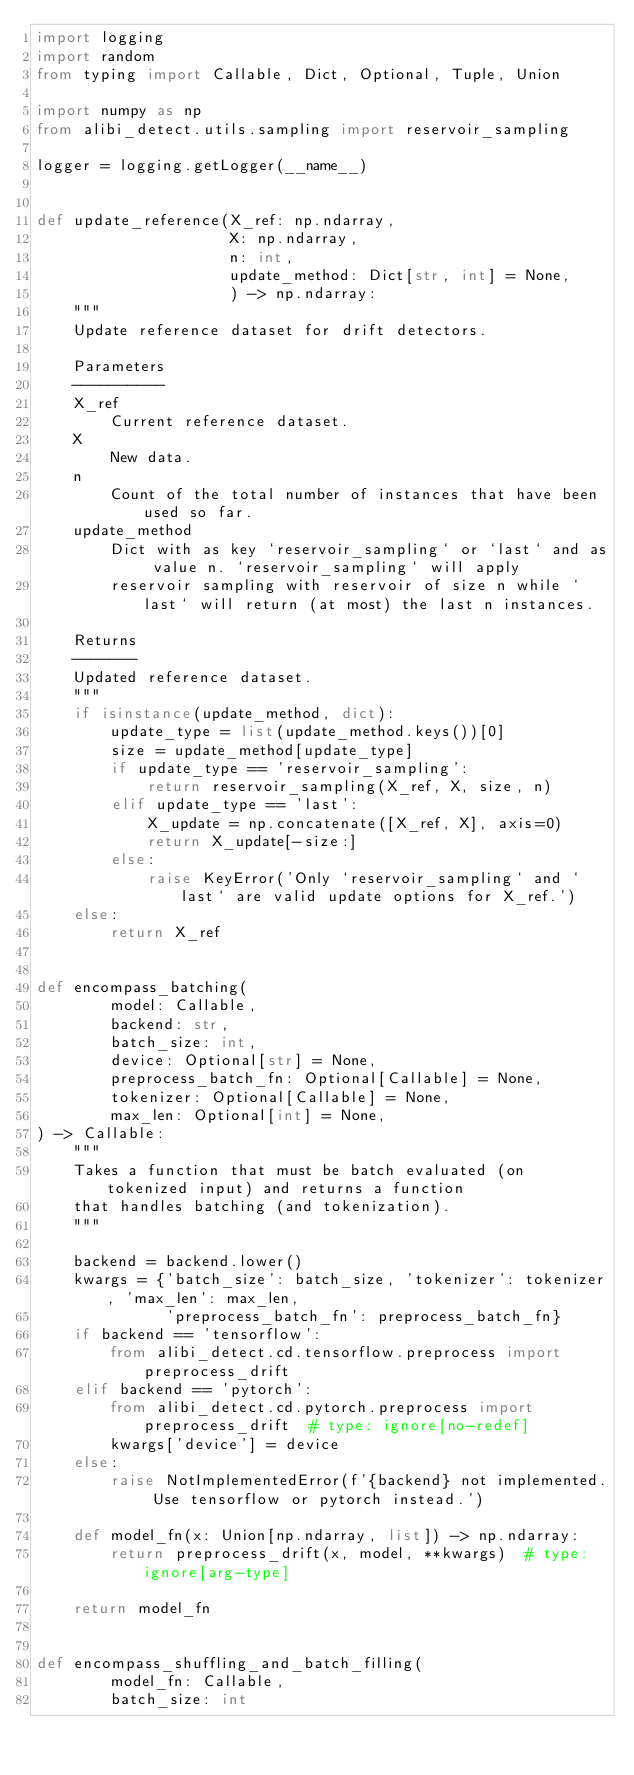Convert code to text. <code><loc_0><loc_0><loc_500><loc_500><_Python_>import logging
import random
from typing import Callable, Dict, Optional, Tuple, Union

import numpy as np
from alibi_detect.utils.sampling import reservoir_sampling

logger = logging.getLogger(__name__)


def update_reference(X_ref: np.ndarray,
                     X: np.ndarray,
                     n: int,
                     update_method: Dict[str, int] = None,
                     ) -> np.ndarray:
    """
    Update reference dataset for drift detectors.

    Parameters
    ----------
    X_ref
        Current reference dataset.
    X
        New data.
    n
        Count of the total number of instances that have been used so far.
    update_method
        Dict with as key `reservoir_sampling` or `last` and as value n. `reservoir_sampling` will apply
        reservoir sampling with reservoir of size n while `last` will return (at most) the last n instances.

    Returns
    -------
    Updated reference dataset.
    """
    if isinstance(update_method, dict):
        update_type = list(update_method.keys())[0]
        size = update_method[update_type]
        if update_type == 'reservoir_sampling':
            return reservoir_sampling(X_ref, X, size, n)
        elif update_type == 'last':
            X_update = np.concatenate([X_ref, X], axis=0)
            return X_update[-size:]
        else:
            raise KeyError('Only `reservoir_sampling` and `last` are valid update options for X_ref.')
    else:
        return X_ref


def encompass_batching(
        model: Callable,
        backend: str,
        batch_size: int,
        device: Optional[str] = None,
        preprocess_batch_fn: Optional[Callable] = None,
        tokenizer: Optional[Callable] = None,
        max_len: Optional[int] = None,
) -> Callable:
    """
    Takes a function that must be batch evaluated (on tokenized input) and returns a function
    that handles batching (and tokenization).
    """

    backend = backend.lower()
    kwargs = {'batch_size': batch_size, 'tokenizer': tokenizer, 'max_len': max_len,
              'preprocess_batch_fn': preprocess_batch_fn}
    if backend == 'tensorflow':
        from alibi_detect.cd.tensorflow.preprocess import preprocess_drift
    elif backend == 'pytorch':
        from alibi_detect.cd.pytorch.preprocess import preprocess_drift  # type: ignore[no-redef]
        kwargs['device'] = device
    else:
        raise NotImplementedError(f'{backend} not implemented. Use tensorflow or pytorch instead.')

    def model_fn(x: Union[np.ndarray, list]) -> np.ndarray:
        return preprocess_drift(x, model, **kwargs)  # type: ignore[arg-type]

    return model_fn


def encompass_shuffling_and_batch_filling(
        model_fn: Callable,
        batch_size: int</code> 